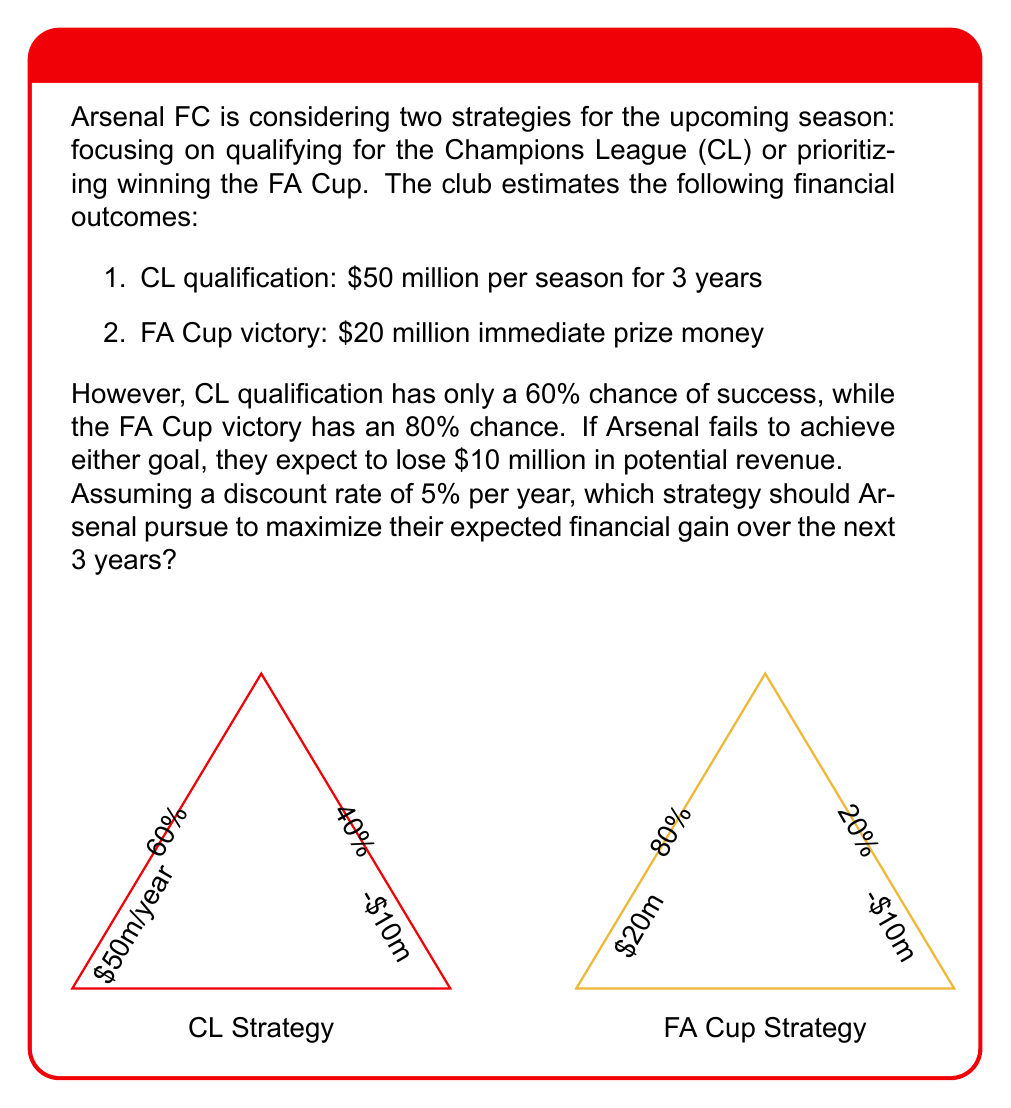Can you solve this math problem? Let's approach this problem step-by-step:

1. Calculate the present value of the Champions League strategy:

   Success scenario (60% chance):
   $$PV_{CL} = 50 + \frac{50}{1.05} + \frac{50}{1.05^2} = 50 + 47.62 + 45.35 = 142.97$$

   Failure scenario (40% chance): -$10 million

   Expected value: 
   $$EV_{CL} = 0.6 \times 142.97 + 0.4 \times (-10) = 85.78 - 4 = $81.78 \text{ million}$$

2. Calculate the present value of the FA Cup strategy:

   Success scenario (80% chance): $20 million
   Failure scenario (20% chance): -$10 million

   Expected value:
   $$EV_{FA} = 0.8 \times 20 + 0.2 \times (-10) = 16 - 2 = $14 \text{ million}$$

3. Compare the two strategies:

   The Champions League strategy has a higher expected value ($81.78 million) compared to the FA Cup strategy ($14 million).

4. Consider the risk:

   While the CL strategy has a higher potential reward, it also carries more risk due to the lower probability of success and the multi-year commitment.

5. Decision:

   From a purely financial perspective, Arsenal should pursue the Champions League qualification strategy, as it offers a significantly higher expected value over the three-year period.
Answer: Pursue Champions League qualification ($81.78 million expected value) 